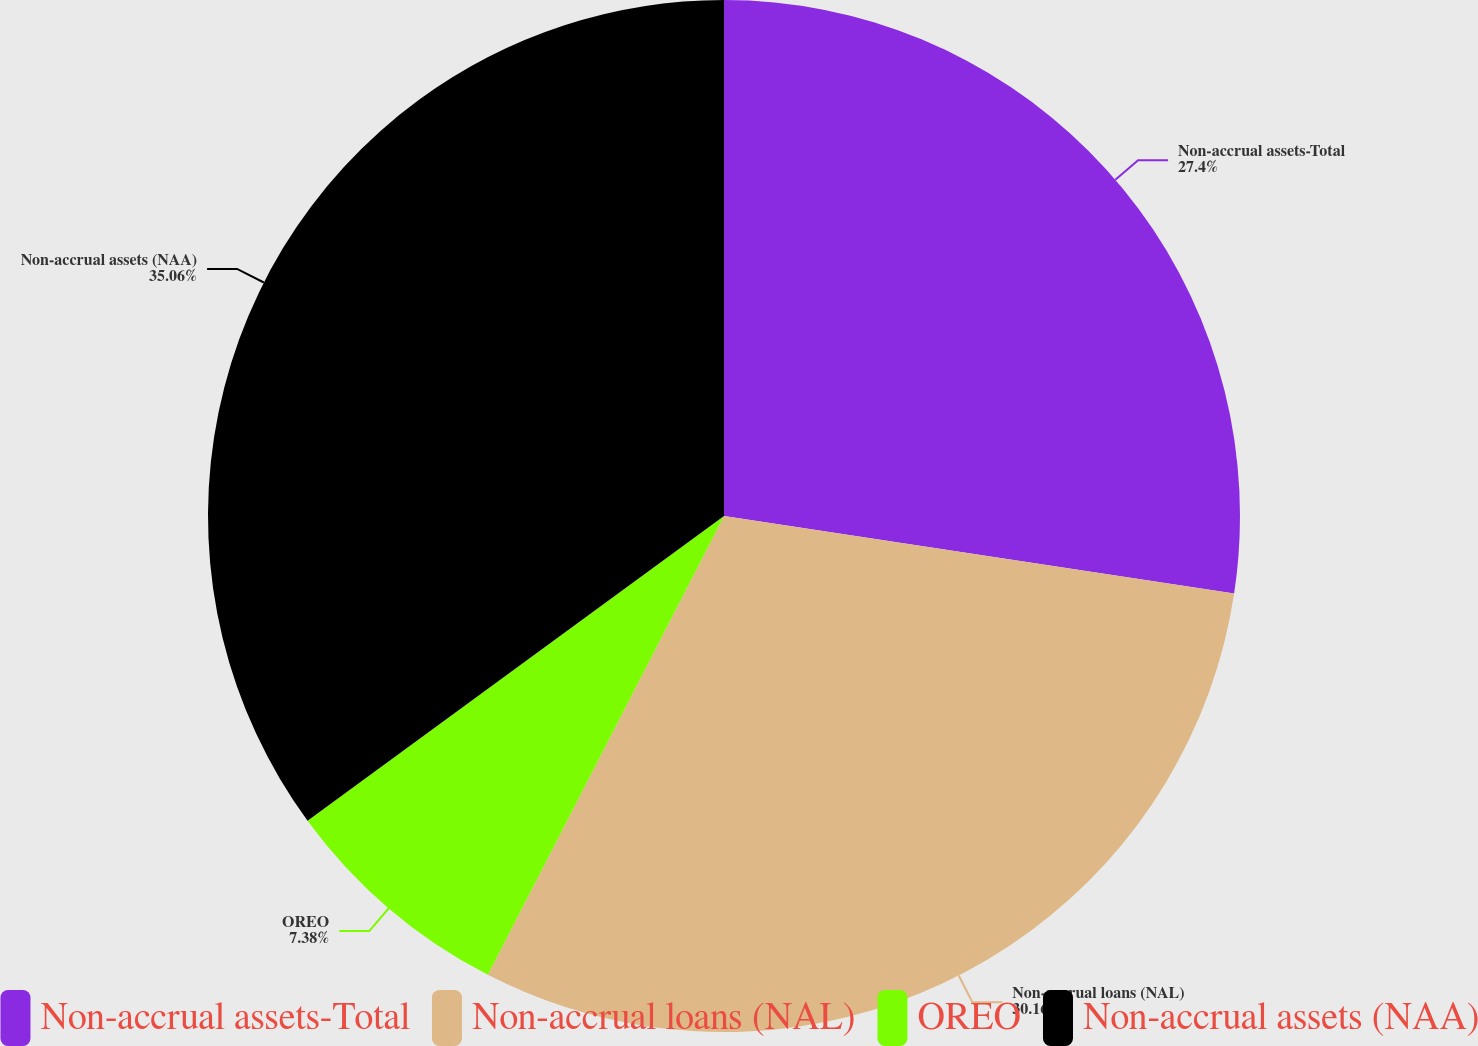<chart> <loc_0><loc_0><loc_500><loc_500><pie_chart><fcel>Non-accrual assets-Total<fcel>Non-accrual loans (NAL)<fcel>OREO<fcel>Non-accrual assets (NAA)<nl><fcel>27.4%<fcel>30.16%<fcel>7.38%<fcel>35.05%<nl></chart> 